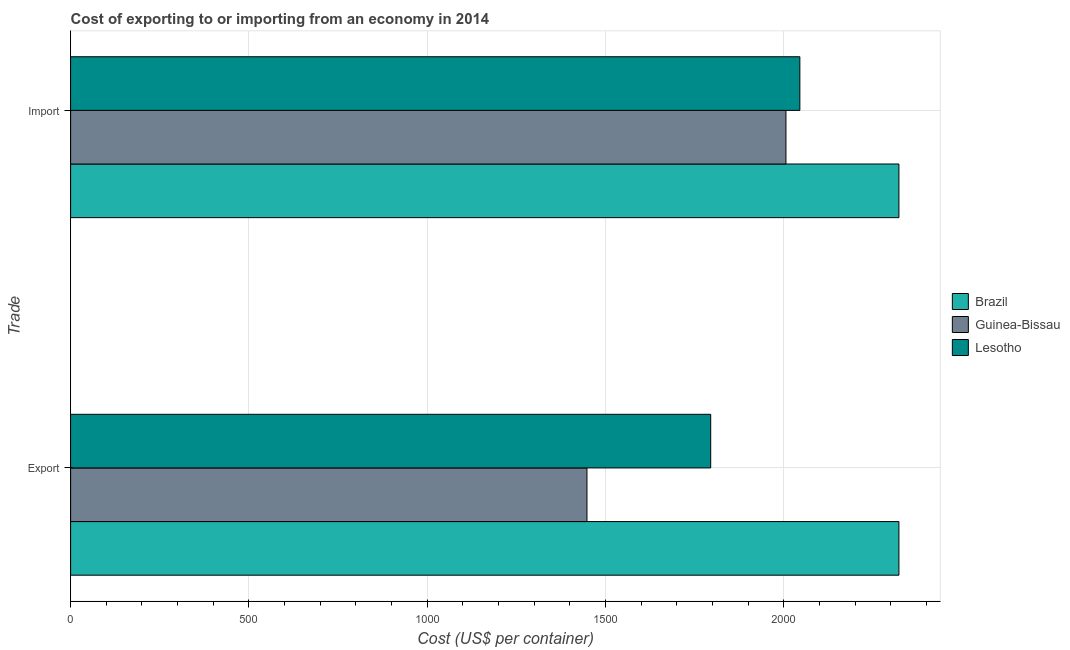How many groups of bars are there?
Give a very brief answer. 2. Are the number of bars on each tick of the Y-axis equal?
Keep it short and to the point. Yes. How many bars are there on the 2nd tick from the bottom?
Offer a very short reply. 3. What is the label of the 2nd group of bars from the top?
Keep it short and to the point. Export. What is the import cost in Brazil?
Your response must be concise. 2322.8. Across all countries, what is the maximum export cost?
Provide a succinct answer. 2322.8. Across all countries, what is the minimum import cost?
Keep it short and to the point. 2006. In which country was the import cost minimum?
Make the answer very short. Guinea-Bissau. What is the total import cost in the graph?
Keep it short and to the point. 6373.8. What is the difference between the import cost in Lesotho and that in Brazil?
Your response must be concise. -277.8. What is the difference between the import cost in Guinea-Bissau and the export cost in Brazil?
Your answer should be very brief. -316.8. What is the average export cost per country?
Provide a short and direct response. 1855.27. What is the difference between the export cost and import cost in Lesotho?
Keep it short and to the point. -250. In how many countries, is the import cost greater than 700 US$?
Offer a very short reply. 3. What is the ratio of the export cost in Brazil to that in Lesotho?
Your response must be concise. 1.29. In how many countries, is the import cost greater than the average import cost taken over all countries?
Make the answer very short. 1. What does the 1st bar from the bottom in Import represents?
Give a very brief answer. Brazil. How many bars are there?
Provide a succinct answer. 6. Are all the bars in the graph horizontal?
Offer a terse response. Yes. What is the difference between two consecutive major ticks on the X-axis?
Offer a terse response. 500. What is the title of the graph?
Provide a short and direct response. Cost of exporting to or importing from an economy in 2014. What is the label or title of the X-axis?
Your answer should be compact. Cost (US$ per container). What is the label or title of the Y-axis?
Ensure brevity in your answer.  Trade. What is the Cost (US$ per container) in Brazil in Export?
Make the answer very short. 2322.8. What is the Cost (US$ per container) in Guinea-Bissau in Export?
Offer a very short reply. 1448. What is the Cost (US$ per container) in Lesotho in Export?
Keep it short and to the point. 1795. What is the Cost (US$ per container) of Brazil in Import?
Your response must be concise. 2322.8. What is the Cost (US$ per container) in Guinea-Bissau in Import?
Keep it short and to the point. 2006. What is the Cost (US$ per container) in Lesotho in Import?
Provide a succinct answer. 2045. Across all Trade, what is the maximum Cost (US$ per container) in Brazil?
Your response must be concise. 2322.8. Across all Trade, what is the maximum Cost (US$ per container) in Guinea-Bissau?
Make the answer very short. 2006. Across all Trade, what is the maximum Cost (US$ per container) of Lesotho?
Provide a short and direct response. 2045. Across all Trade, what is the minimum Cost (US$ per container) in Brazil?
Your answer should be compact. 2322.8. Across all Trade, what is the minimum Cost (US$ per container) of Guinea-Bissau?
Your response must be concise. 1448. Across all Trade, what is the minimum Cost (US$ per container) of Lesotho?
Make the answer very short. 1795. What is the total Cost (US$ per container) in Brazil in the graph?
Provide a short and direct response. 4645.6. What is the total Cost (US$ per container) in Guinea-Bissau in the graph?
Keep it short and to the point. 3454. What is the total Cost (US$ per container) of Lesotho in the graph?
Give a very brief answer. 3840. What is the difference between the Cost (US$ per container) in Guinea-Bissau in Export and that in Import?
Your answer should be very brief. -558. What is the difference between the Cost (US$ per container) in Lesotho in Export and that in Import?
Your answer should be compact. -250. What is the difference between the Cost (US$ per container) in Brazil in Export and the Cost (US$ per container) in Guinea-Bissau in Import?
Your answer should be compact. 316.8. What is the difference between the Cost (US$ per container) of Brazil in Export and the Cost (US$ per container) of Lesotho in Import?
Your response must be concise. 277.8. What is the difference between the Cost (US$ per container) in Guinea-Bissau in Export and the Cost (US$ per container) in Lesotho in Import?
Provide a short and direct response. -597. What is the average Cost (US$ per container) of Brazil per Trade?
Ensure brevity in your answer.  2322.8. What is the average Cost (US$ per container) in Guinea-Bissau per Trade?
Your response must be concise. 1727. What is the average Cost (US$ per container) of Lesotho per Trade?
Your answer should be compact. 1920. What is the difference between the Cost (US$ per container) of Brazil and Cost (US$ per container) of Guinea-Bissau in Export?
Provide a short and direct response. 874.8. What is the difference between the Cost (US$ per container) in Brazil and Cost (US$ per container) in Lesotho in Export?
Provide a short and direct response. 527.8. What is the difference between the Cost (US$ per container) of Guinea-Bissau and Cost (US$ per container) of Lesotho in Export?
Provide a succinct answer. -347. What is the difference between the Cost (US$ per container) of Brazil and Cost (US$ per container) of Guinea-Bissau in Import?
Give a very brief answer. 316.8. What is the difference between the Cost (US$ per container) in Brazil and Cost (US$ per container) in Lesotho in Import?
Offer a very short reply. 277.8. What is the difference between the Cost (US$ per container) of Guinea-Bissau and Cost (US$ per container) of Lesotho in Import?
Keep it short and to the point. -39. What is the ratio of the Cost (US$ per container) of Guinea-Bissau in Export to that in Import?
Ensure brevity in your answer.  0.72. What is the ratio of the Cost (US$ per container) in Lesotho in Export to that in Import?
Provide a short and direct response. 0.88. What is the difference between the highest and the second highest Cost (US$ per container) in Guinea-Bissau?
Offer a very short reply. 558. What is the difference between the highest and the second highest Cost (US$ per container) of Lesotho?
Your answer should be very brief. 250. What is the difference between the highest and the lowest Cost (US$ per container) of Brazil?
Offer a terse response. 0. What is the difference between the highest and the lowest Cost (US$ per container) of Guinea-Bissau?
Your answer should be compact. 558. What is the difference between the highest and the lowest Cost (US$ per container) of Lesotho?
Provide a succinct answer. 250. 